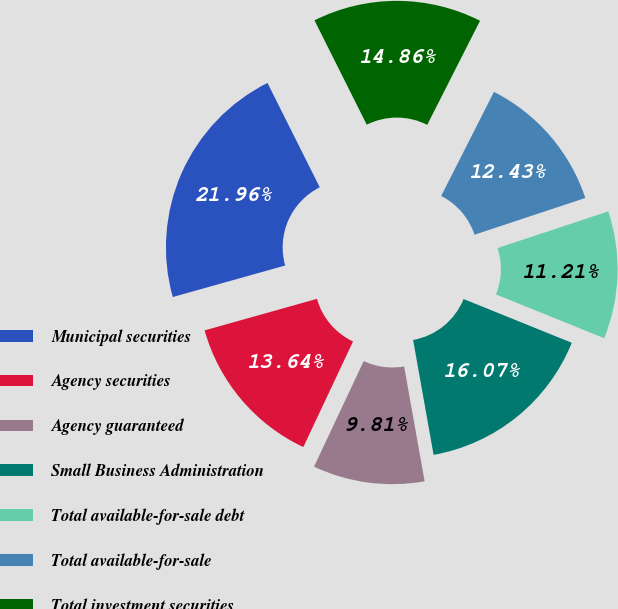Convert chart. <chart><loc_0><loc_0><loc_500><loc_500><pie_chart><fcel>Municipal securities<fcel>Agency securities<fcel>Agency guaranteed<fcel>Small Business Administration<fcel>Total available-for-sale debt<fcel>Total available-for-sale<fcel>Total investment securities<nl><fcel>21.96%<fcel>13.64%<fcel>9.81%<fcel>16.07%<fcel>11.21%<fcel>12.43%<fcel>14.86%<nl></chart> 